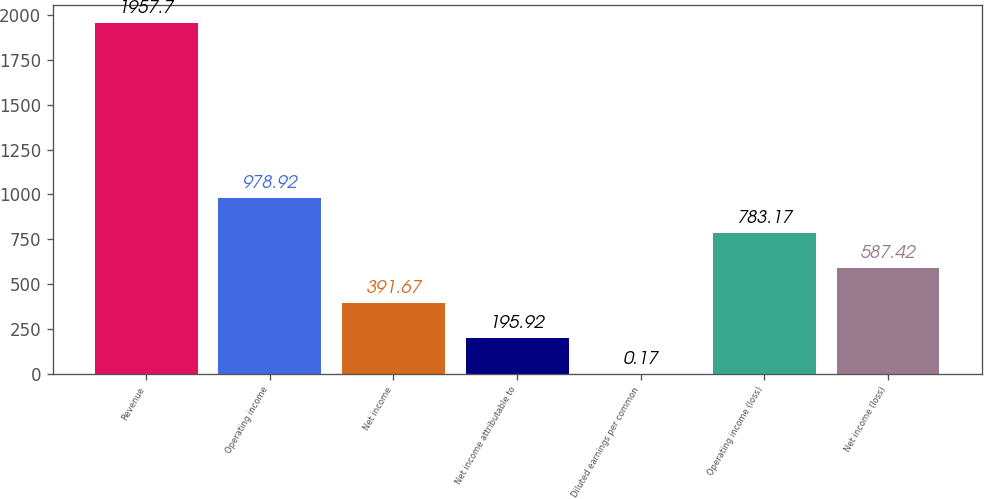Convert chart to OTSL. <chart><loc_0><loc_0><loc_500><loc_500><bar_chart><fcel>Revenue<fcel>Operating income<fcel>Net income<fcel>Net income attributable to<fcel>Diluted earnings per common<fcel>Operating income (loss)<fcel>Net income (loss)<nl><fcel>1957.7<fcel>978.92<fcel>391.67<fcel>195.92<fcel>0.17<fcel>783.17<fcel>587.42<nl></chart> 